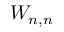Convert formula to latex. <formula><loc_0><loc_0><loc_500><loc_500>W _ { n , n }</formula> 